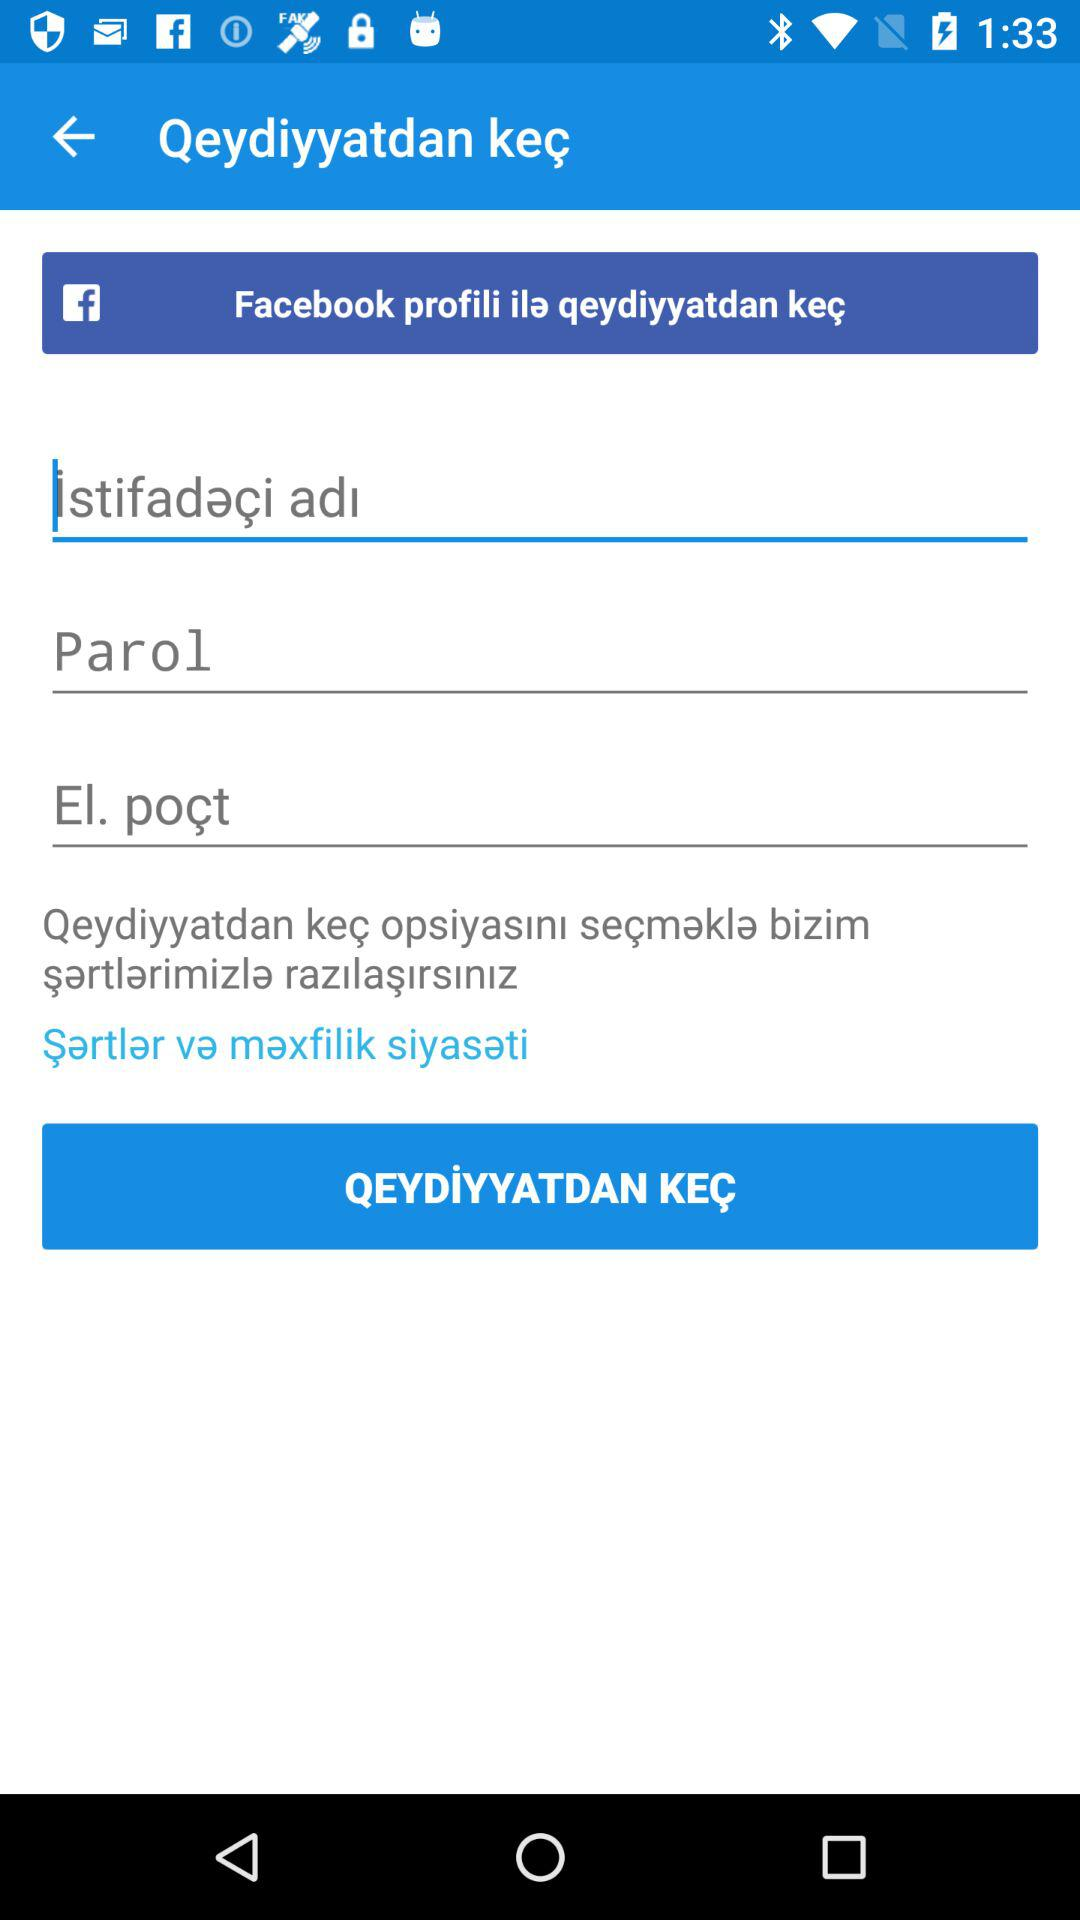How many text fields are there in the registration form?
Answer the question using a single word or phrase. 3 